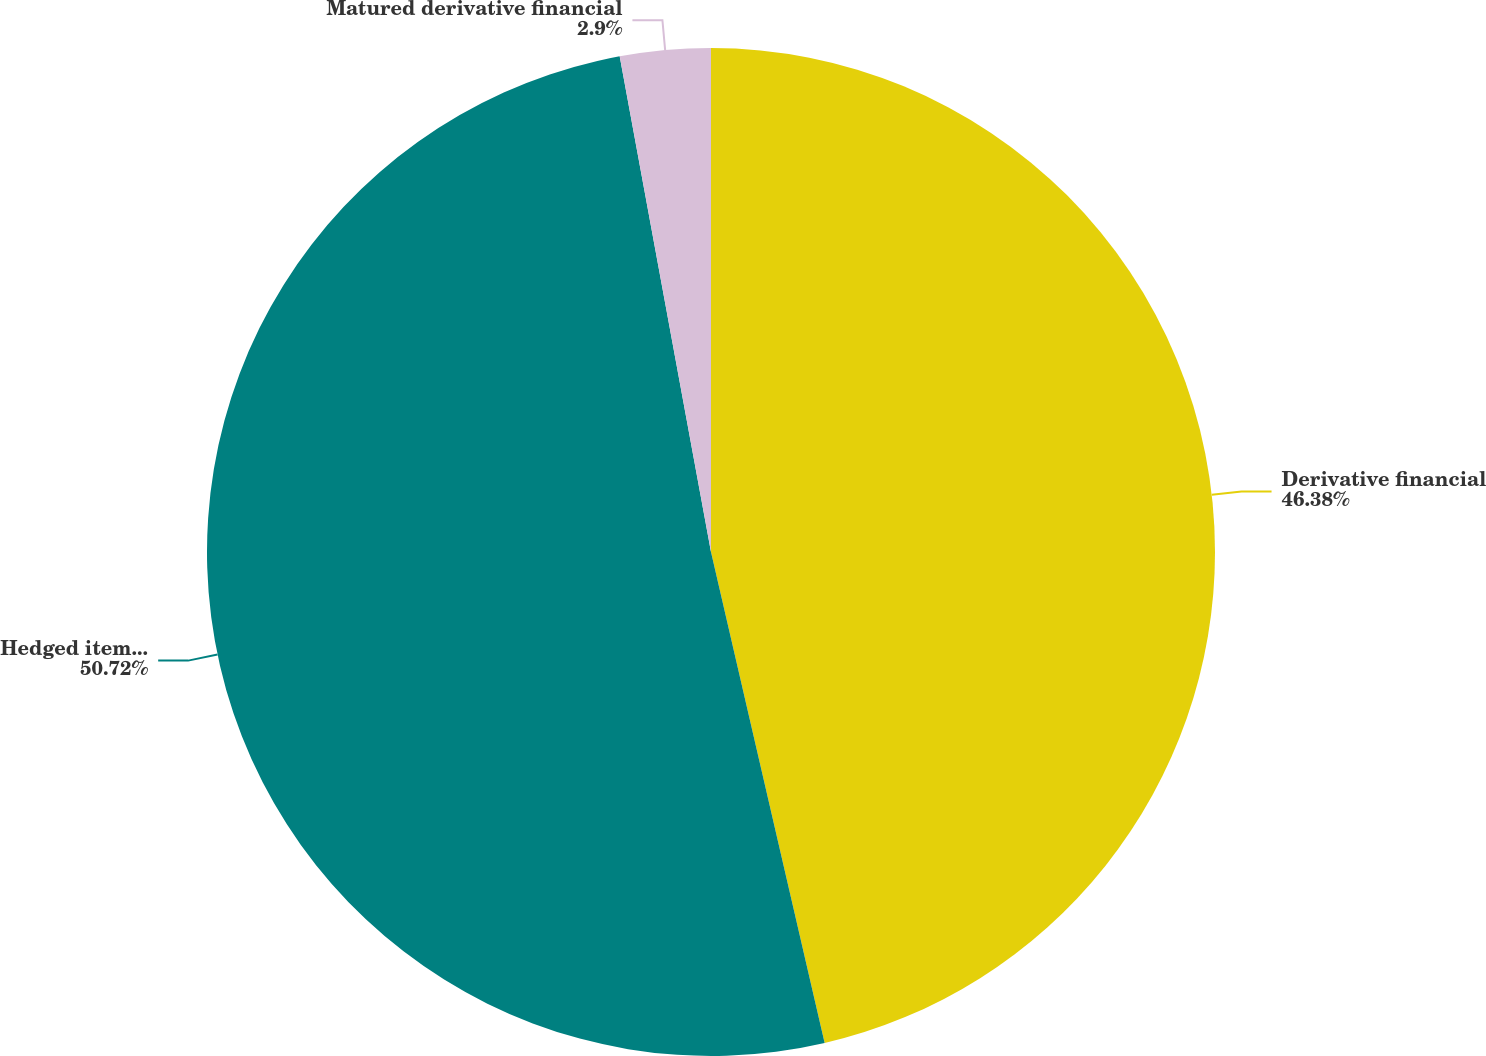Convert chart to OTSL. <chart><loc_0><loc_0><loc_500><loc_500><pie_chart><fcel>Derivative financial<fcel>Hedged item - firm sales<fcel>Matured derivative financial<nl><fcel>46.38%<fcel>50.72%<fcel>2.9%<nl></chart> 